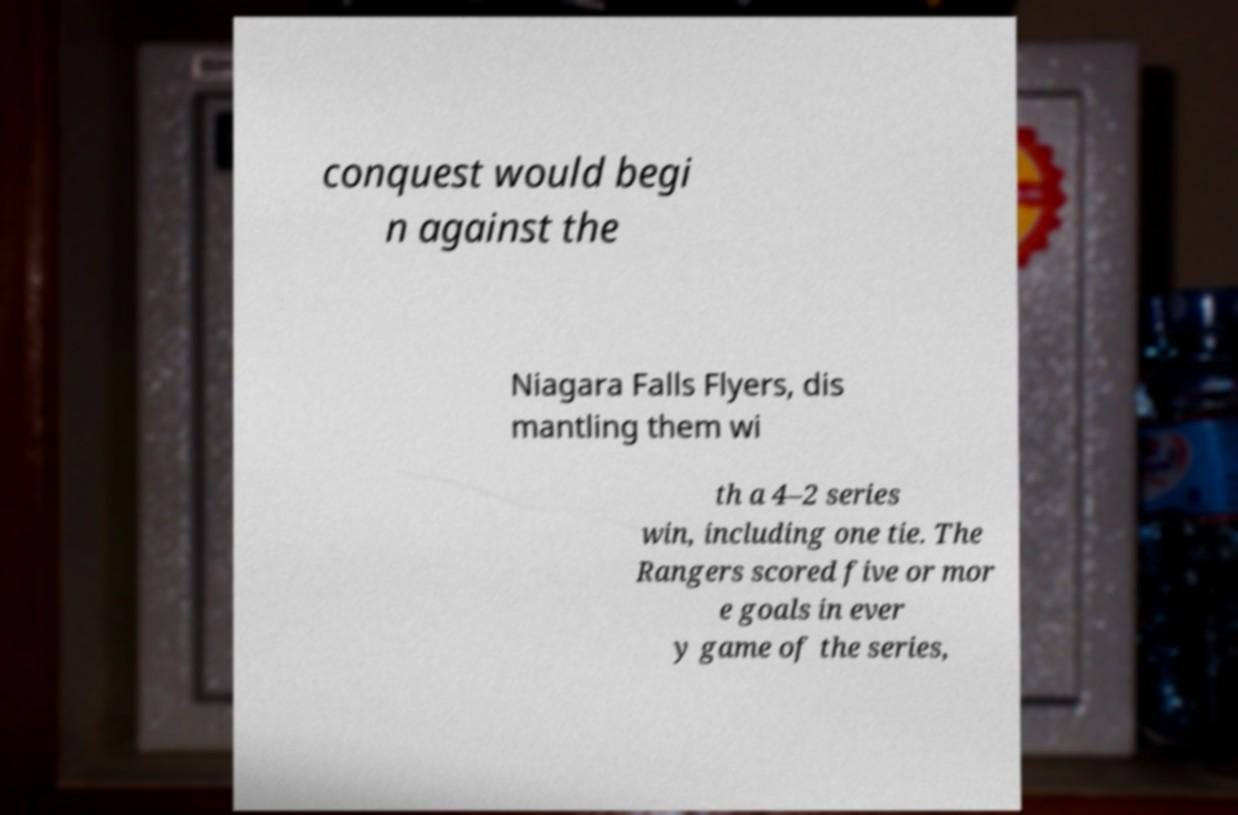I need the written content from this picture converted into text. Can you do that? conquest would begi n against the Niagara Falls Flyers, dis mantling them wi th a 4–2 series win, including one tie. The Rangers scored five or mor e goals in ever y game of the series, 